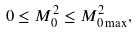Convert formula to latex. <formula><loc_0><loc_0><loc_500><loc_500>0 \leq M _ { 0 } ^ { 2 } \leq M _ { 0 \max } ^ { 2 } ,</formula> 